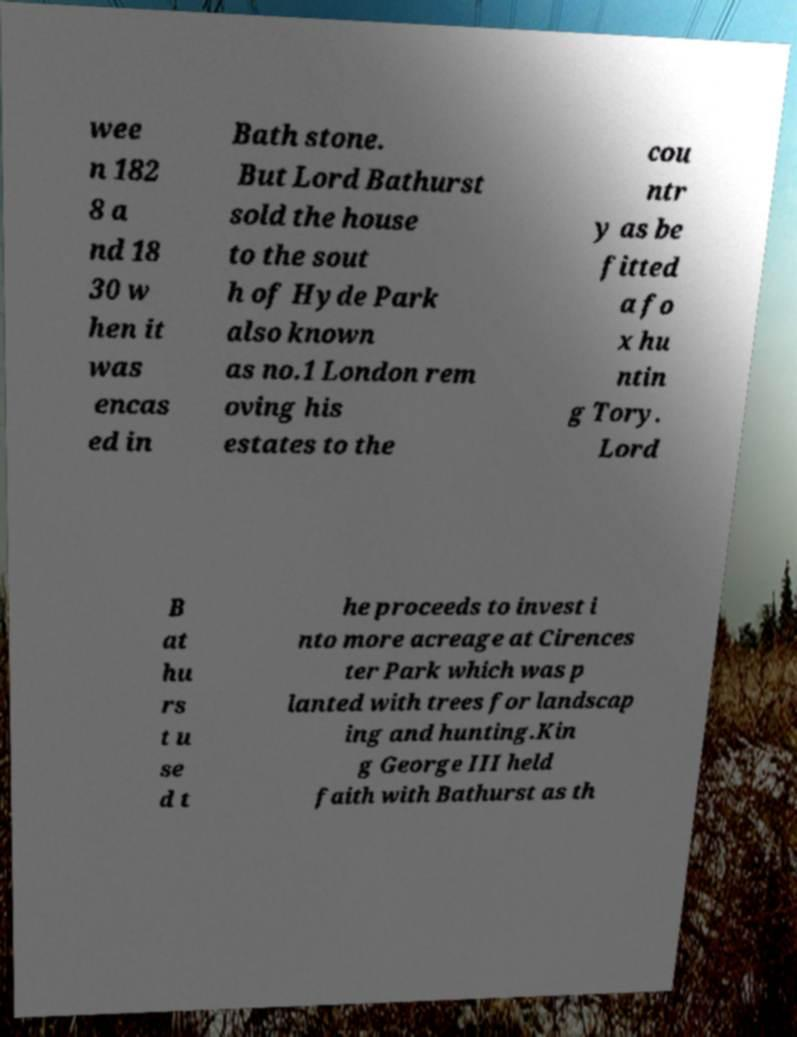Can you read and provide the text displayed in the image?This photo seems to have some interesting text. Can you extract and type it out for me? wee n 182 8 a nd 18 30 w hen it was encas ed in Bath stone. But Lord Bathurst sold the house to the sout h of Hyde Park also known as no.1 London rem oving his estates to the cou ntr y as be fitted a fo x hu ntin g Tory. Lord B at hu rs t u se d t he proceeds to invest i nto more acreage at Cirences ter Park which was p lanted with trees for landscap ing and hunting.Kin g George III held faith with Bathurst as th 